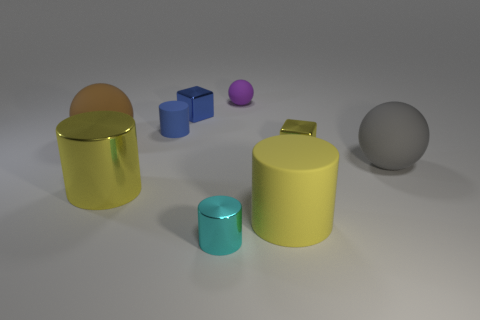Add 1 big yellow rubber cylinders. How many objects exist? 10 Subtract all spheres. How many objects are left? 6 Add 6 yellow cylinders. How many yellow cylinders exist? 8 Subtract 0 purple cylinders. How many objects are left? 9 Subtract all big yellow matte cylinders. Subtract all gray spheres. How many objects are left? 7 Add 8 big yellow cylinders. How many big yellow cylinders are left? 10 